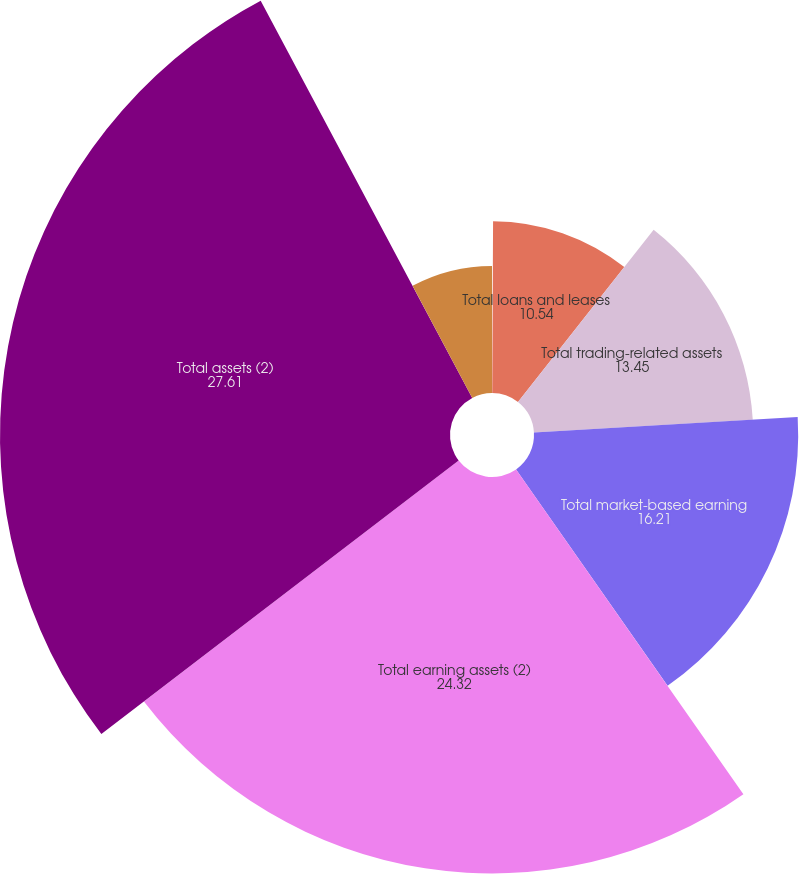<chart> <loc_0><loc_0><loc_500><loc_500><pie_chart><fcel>(Dollars in millions)<fcel>Total loans and leases<fcel>Total trading-related assets<fcel>Total market-based earning<fcel>Total earning assets (2)<fcel>Total assets (2)<fcel>Total deposits<nl><fcel>0.08%<fcel>10.54%<fcel>13.45%<fcel>16.21%<fcel>24.32%<fcel>27.61%<fcel>7.79%<nl></chart> 